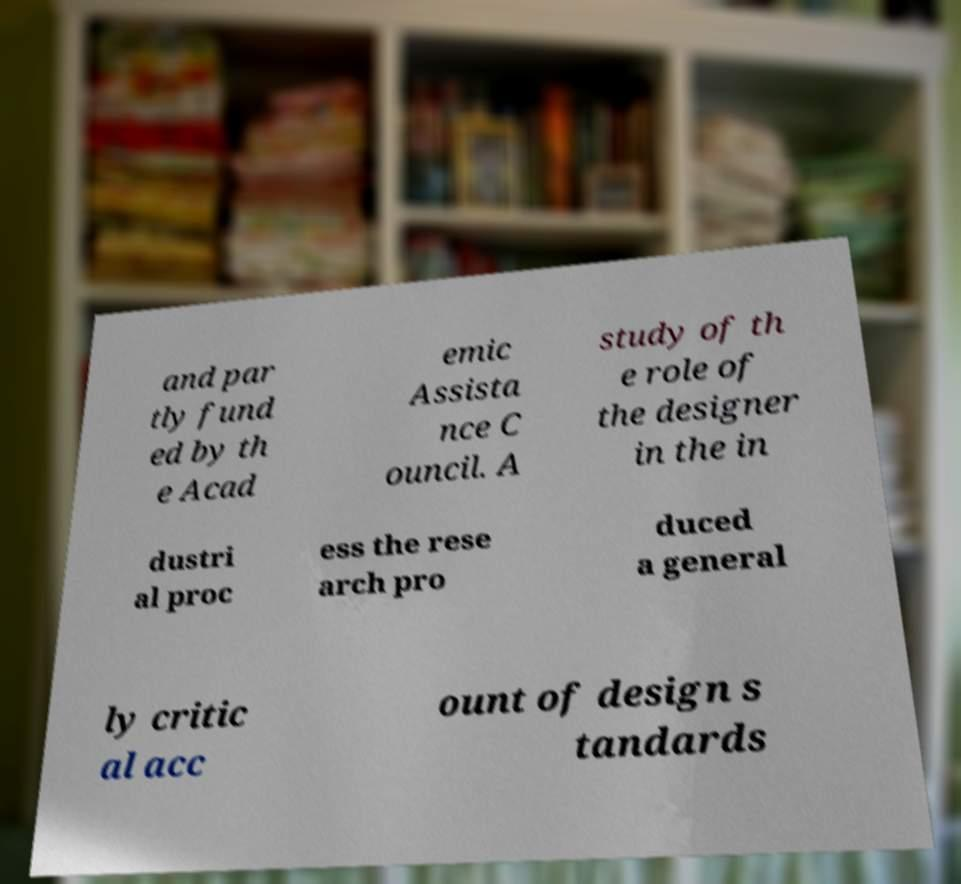Could you assist in decoding the text presented in this image and type it out clearly? and par tly fund ed by th e Acad emic Assista nce C ouncil. A study of th e role of the designer in the in dustri al proc ess the rese arch pro duced a general ly critic al acc ount of design s tandards 